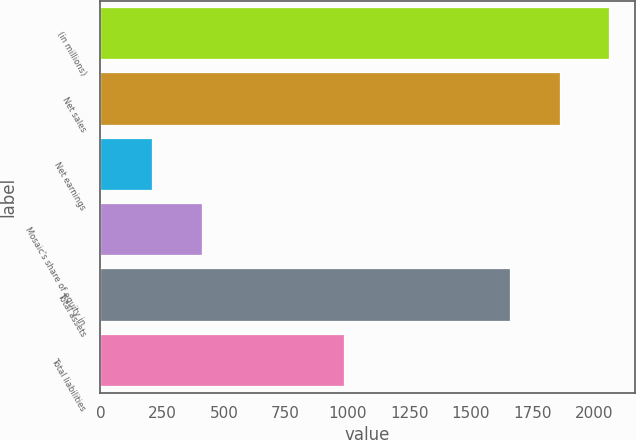Convert chart to OTSL. <chart><loc_0><loc_0><loc_500><loc_500><bar_chart><fcel>(in millions)<fcel>Net sales<fcel>Net earnings<fcel>Mosaic's share of equity in<fcel>Total assets<fcel>Total liabilities<nl><fcel>2058.92<fcel>1858.71<fcel>211.11<fcel>411.32<fcel>1658.5<fcel>985.3<nl></chart> 